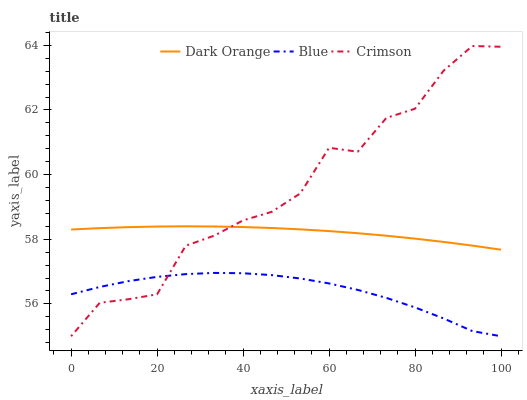Does Blue have the minimum area under the curve?
Answer yes or no. Yes. Does Crimson have the maximum area under the curve?
Answer yes or no. Yes. Does Dark Orange have the minimum area under the curve?
Answer yes or no. No. Does Dark Orange have the maximum area under the curve?
Answer yes or no. No. Is Dark Orange the smoothest?
Answer yes or no. Yes. Is Crimson the roughest?
Answer yes or no. Yes. Is Crimson the smoothest?
Answer yes or no. No. Is Dark Orange the roughest?
Answer yes or no. No. Does Blue have the lowest value?
Answer yes or no. Yes. Does Dark Orange have the lowest value?
Answer yes or no. No. Does Crimson have the highest value?
Answer yes or no. Yes. Does Dark Orange have the highest value?
Answer yes or no. No. Is Blue less than Dark Orange?
Answer yes or no. Yes. Is Dark Orange greater than Blue?
Answer yes or no. Yes. Does Blue intersect Crimson?
Answer yes or no. Yes. Is Blue less than Crimson?
Answer yes or no. No. Is Blue greater than Crimson?
Answer yes or no. No. Does Blue intersect Dark Orange?
Answer yes or no. No. 